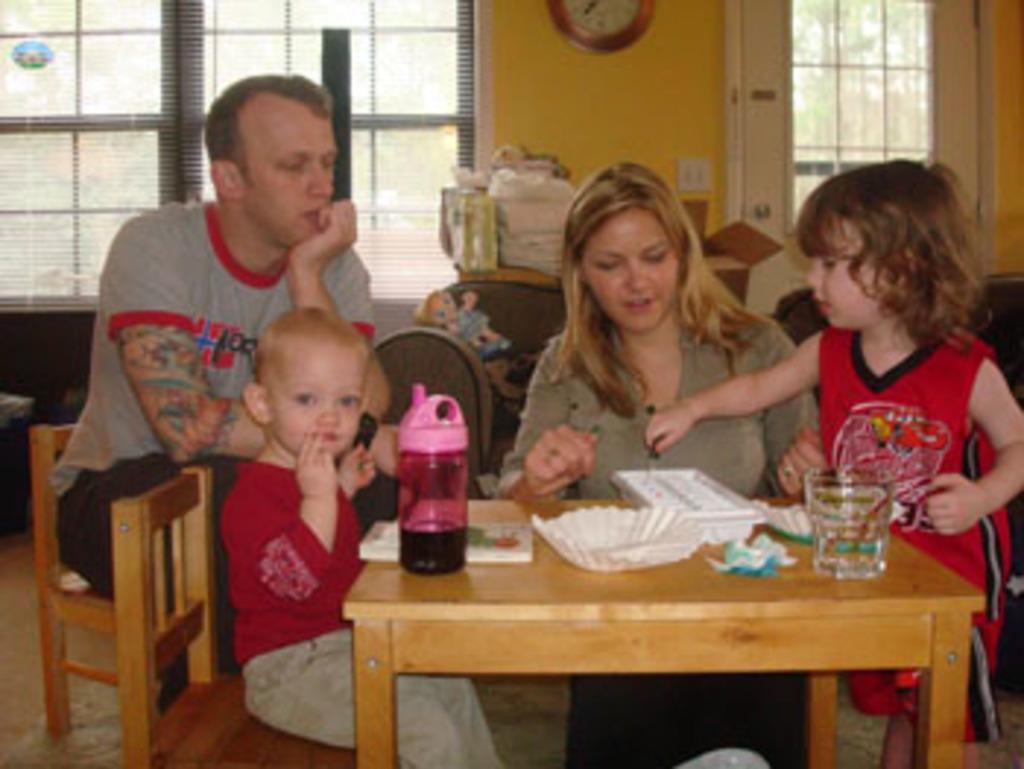Could you give a brief overview of what you see in this image? In this image, there is an inside view of a house. There are four persons wearing colorful clothes. There are two persons on the left side of the image sitting on chairs. There is person on the right side of the image standing in front of the table. There is person at the center of the image sitting in front of the table. This table contains bottle, plate and glass. 